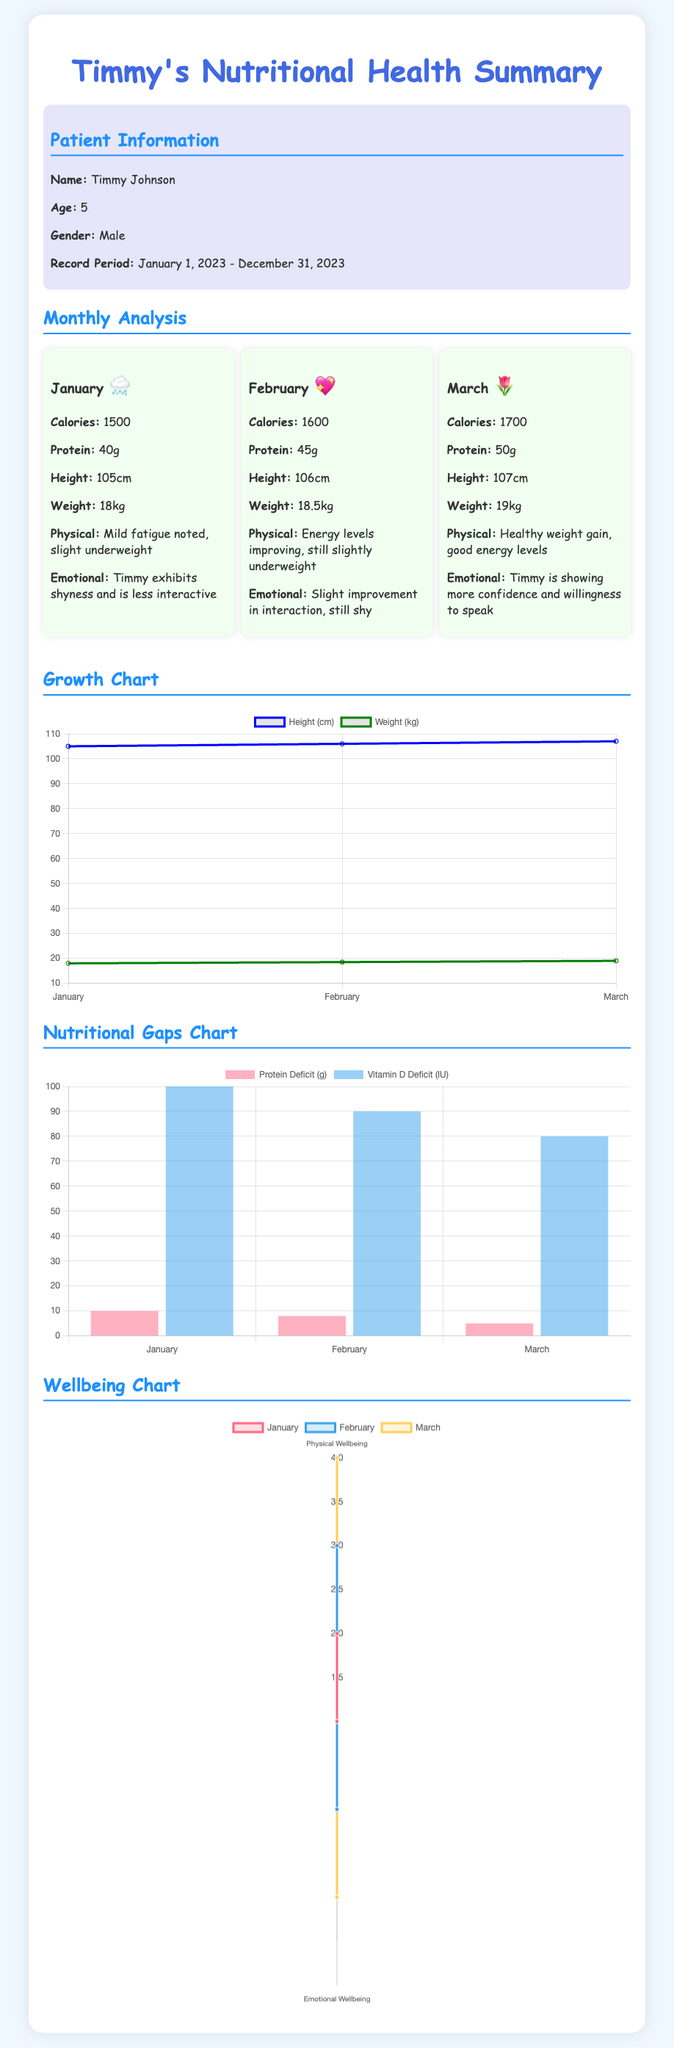what is Timmy's age? Timmy is 5 years old as stated in the patient information section.
Answer: 5 what was Timmy's weight in January? The weight in January was noted to be 18kg in the monthly analysis.
Answer: 18kg how many grams of protein did Timmy consume in March? In the March monthly analysis, the protein intake is noted to be 50g.
Answer: 50g which month shows the highest physical wellbeing score? The wellbeing chart displays physical wellbeing scores for each month, showing March with the highest score of 4.
Answer: March what was the protein deficit in February? The nutritional gaps chart states that the protein deficit in February was 8g.
Answer: 8g how many centimeters tall was Timmy in February? Timmy's height for February is reported as 106cm in the monthly analysis.
Answer: 106cm which month marks the beginning of Timmy's improved emotional wellbeing? The emotional wellbeing indicated improvement in March, suggesting it is the month where a change began.
Answer: March what is the total calorie intake from January to March? The total calorie intake is the sum from each month's analysis: 1500 + 1600 + 1700 = 4800 cal.
Answer: 4800 cal 